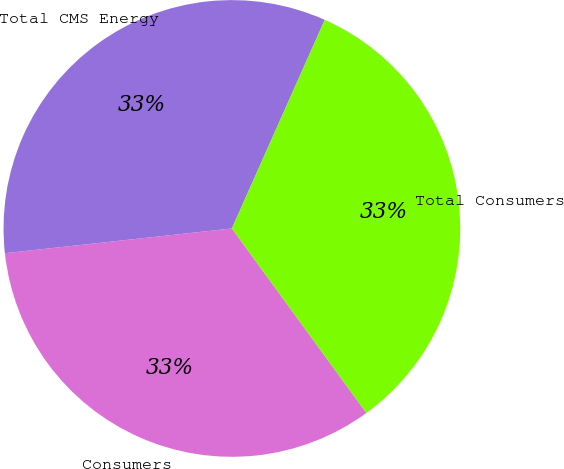Convert chart. <chart><loc_0><loc_0><loc_500><loc_500><pie_chart><fcel>Consumers<fcel>Total CMS Energy<fcel>Total Consumers<nl><fcel>33.3%<fcel>33.4%<fcel>33.31%<nl></chart> 